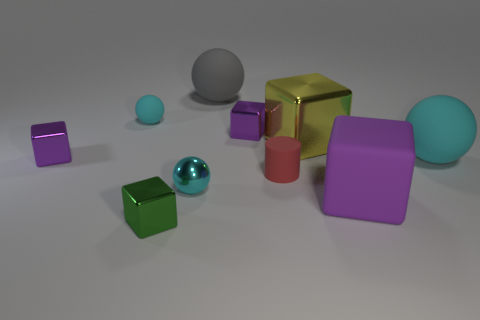Is there anything else of the same color as the cylinder?
Your response must be concise. No. There is another matte thing that is the same size as the red object; what color is it?
Provide a succinct answer. Cyan. Are there fewer tiny green shiny blocks behind the yellow metal thing than small cyan metal objects that are right of the big gray matte ball?
Your answer should be very brief. No. Does the cyan matte ball in front of the yellow shiny thing have the same size as the cyan shiny thing?
Provide a succinct answer. No. There is a cyan object behind the yellow metal thing; what shape is it?
Your response must be concise. Sphere. Is the number of blue matte cylinders greater than the number of gray spheres?
Give a very brief answer. No. There is a tiny ball left of the shiny sphere; is its color the same as the tiny metal ball?
Offer a very short reply. Yes. What number of objects are cyan spheres that are to the right of the tiny red cylinder or purple objects that are behind the big purple block?
Your answer should be compact. 3. How many objects are both behind the big purple matte thing and in front of the big cyan rubber thing?
Offer a very short reply. 2. Is the green cube made of the same material as the large cyan object?
Your response must be concise. No. 